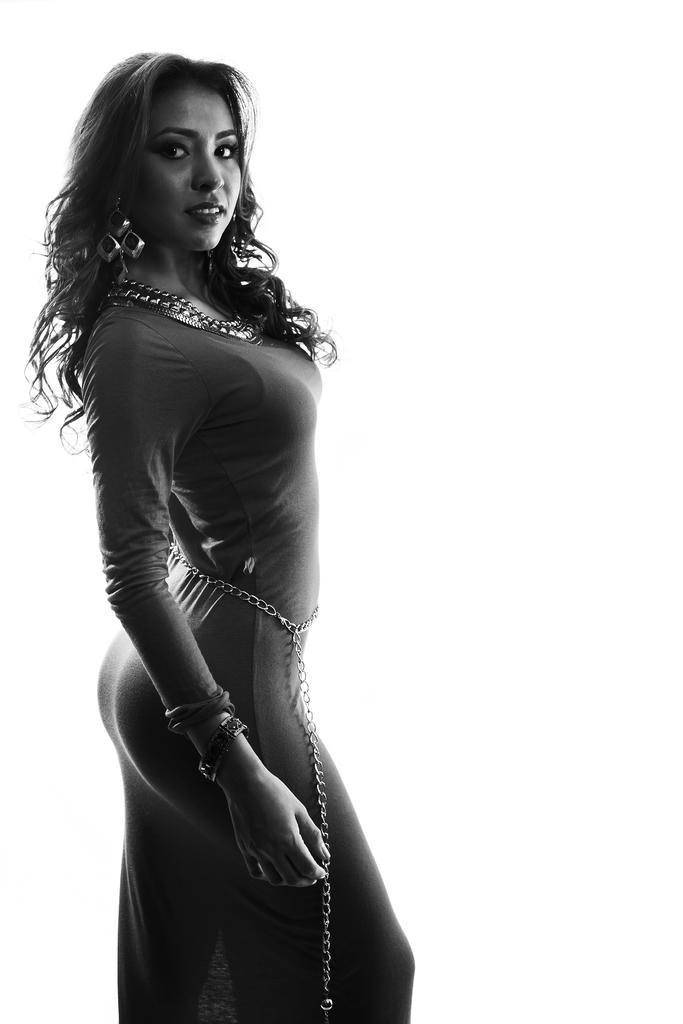Can you describe this image briefly? In this image, we can see a woman is watching and smiling. She wore earrings, chain and waist jewelry. 